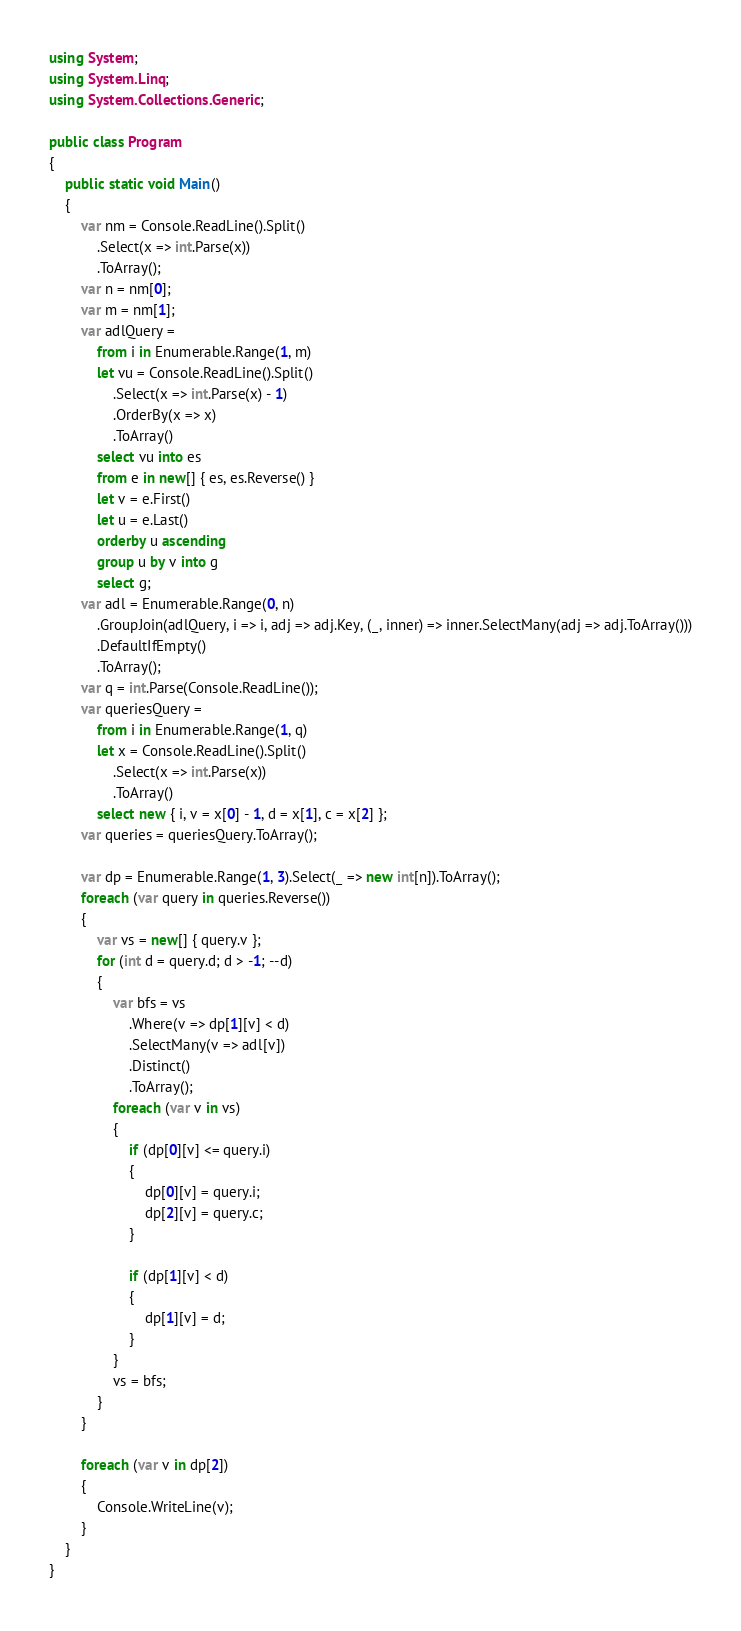<code> <loc_0><loc_0><loc_500><loc_500><_C#_>using System;
using System.Linq;
using System.Collections.Generic;

public class Program
{
    public static void Main()
    {
        var nm = Console.ReadLine().Split()
            .Select(x => int.Parse(x))
            .ToArray();
        var n = nm[0];
        var m = nm[1];
        var adlQuery =
            from i in Enumerable.Range(1, m)
            let vu = Console.ReadLine().Split()
                .Select(x => int.Parse(x) - 1)
                .OrderBy(x => x)
                .ToArray()
            select vu into es
            from e in new[] { es, es.Reverse() }
            let v = e.First()
            let u = e.Last()
            orderby u ascending
            group u by v into g
            select g;
        var adl = Enumerable.Range(0, n)
            .GroupJoin(adlQuery, i => i, adj => adj.Key, (_, inner) => inner.SelectMany(adj => adj.ToArray()))
            .DefaultIfEmpty()
            .ToArray();
        var q = int.Parse(Console.ReadLine());
        var queriesQuery =
            from i in Enumerable.Range(1, q)
            let x = Console.ReadLine().Split()
                .Select(x => int.Parse(x))
                .ToArray()
            select new { i, v = x[0] - 1, d = x[1], c = x[2] };
        var queries = queriesQuery.ToArray();

        var dp = Enumerable.Range(1, 3).Select(_ => new int[n]).ToArray();
        foreach (var query in queries.Reverse())
        {
            var vs = new[] { query.v };
            for (int d = query.d; d > -1; --d)
            {
                var bfs = vs
                    .Where(v => dp[1][v] < d)
                    .SelectMany(v => adl[v])
                    .Distinct()
                    .ToArray();
                foreach (var v in vs)
                {
                    if (dp[0][v] <= query.i)
                    {
                        dp[0][v] = query.i;
                        dp[2][v] = query.c;
                    }

                    if (dp[1][v] < d)
                    {
                        dp[1][v] = d;
                    }
                }
                vs = bfs;
            }
        }

        foreach (var v in dp[2])
        {
            Console.WriteLine(v);
        }
    }
}
</code> 